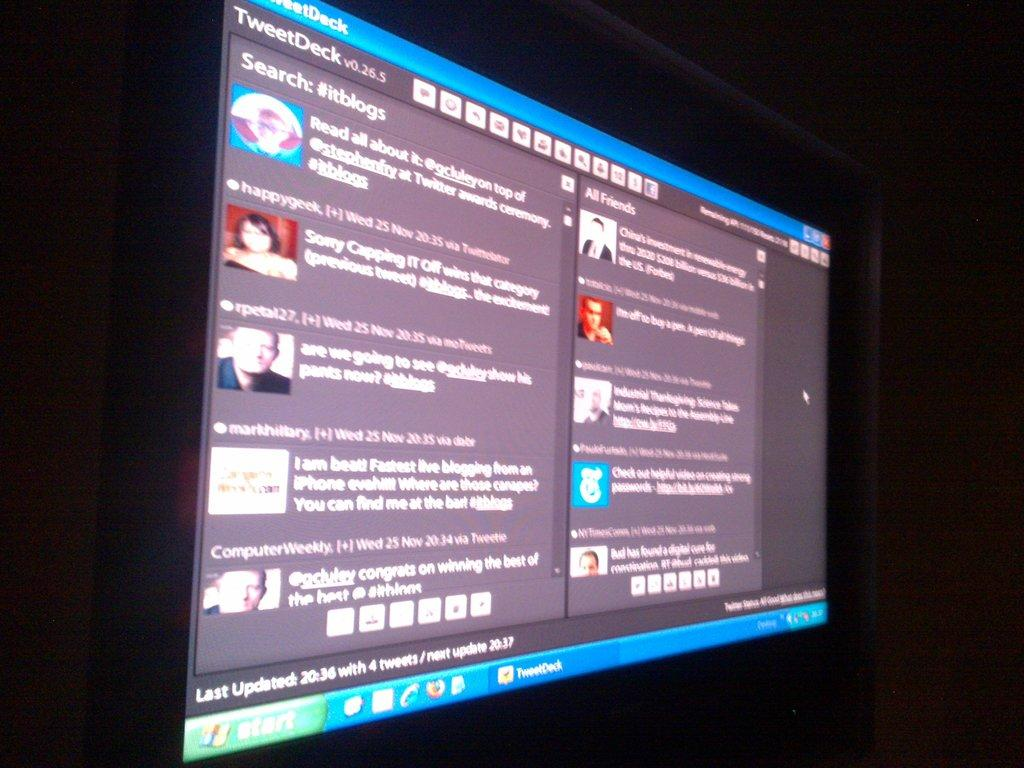<image>
Write a terse but informative summary of the picture. a computer screen with the word start at the bottom left corner 